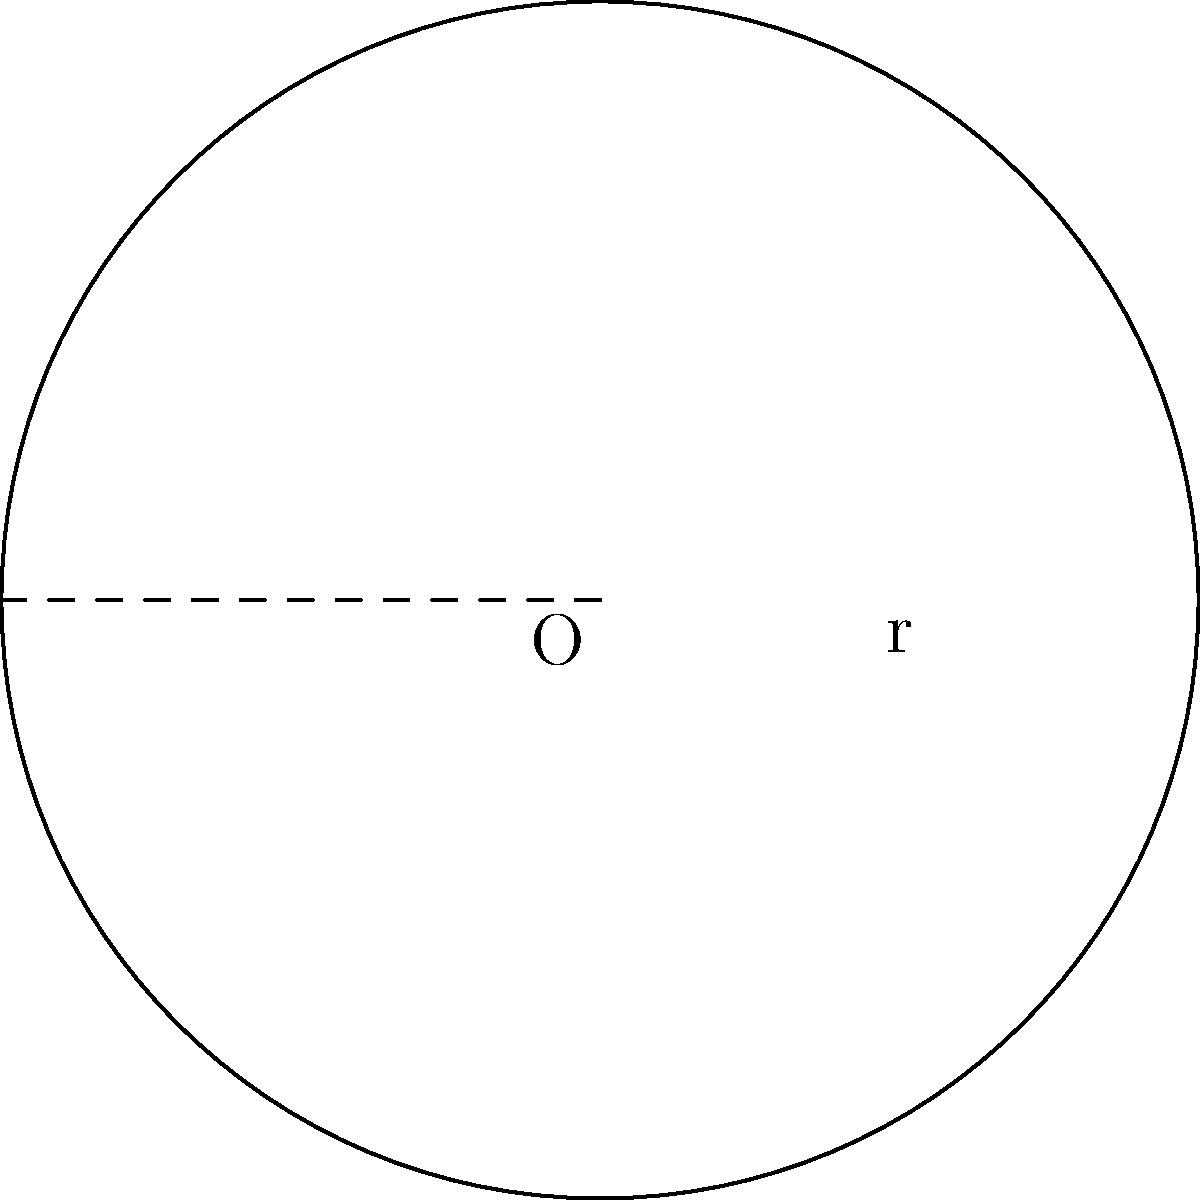As a utility company representative, you're evaluating a circular solar panel array for energy production. If the radius of the array is 50 meters, what is the total area of the solar panel array in square meters? Use $\pi \approx 3.14$ for your calculations. To calculate the area of a circular solar panel array, we need to use the formula for the area of a circle:

$$A = \pi r^2$$

Where:
$A$ = area of the circle
$\pi$ = pi (approximately 3.14)
$r$ = radius of the circle

Given:
- Radius (r) = 50 meters
- $\pi \approx 3.14$

Step 1: Substitute the values into the formula
$$A = \pi r^2$$
$$A = 3.14 \times 50^2$$

Step 2: Calculate the square of the radius
$$A = 3.14 \times 2500$$

Step 3: Multiply to get the final area
$$A = 7850 \text{ square meters}$$

Therefore, the total area of the circular solar panel array is 7850 square meters.
Answer: 7850 square meters 